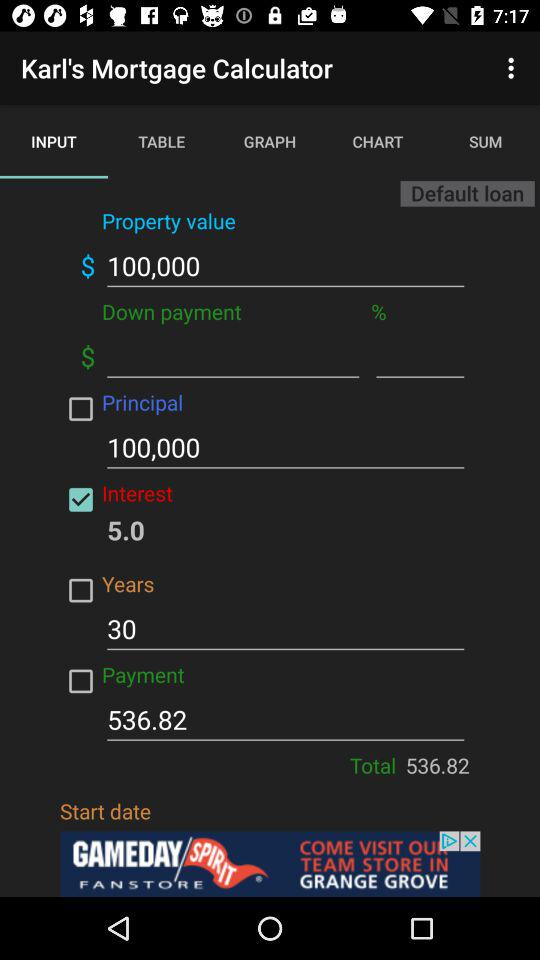What is the rate of interest? The rate of interest is 5. 